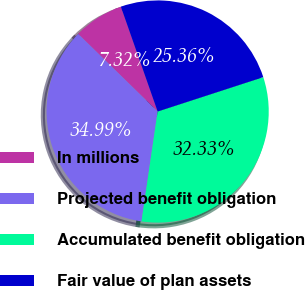<chart> <loc_0><loc_0><loc_500><loc_500><pie_chart><fcel>In millions<fcel>Projected benefit obligation<fcel>Accumulated benefit obligation<fcel>Fair value of plan assets<nl><fcel>7.32%<fcel>34.99%<fcel>32.33%<fcel>25.36%<nl></chart> 